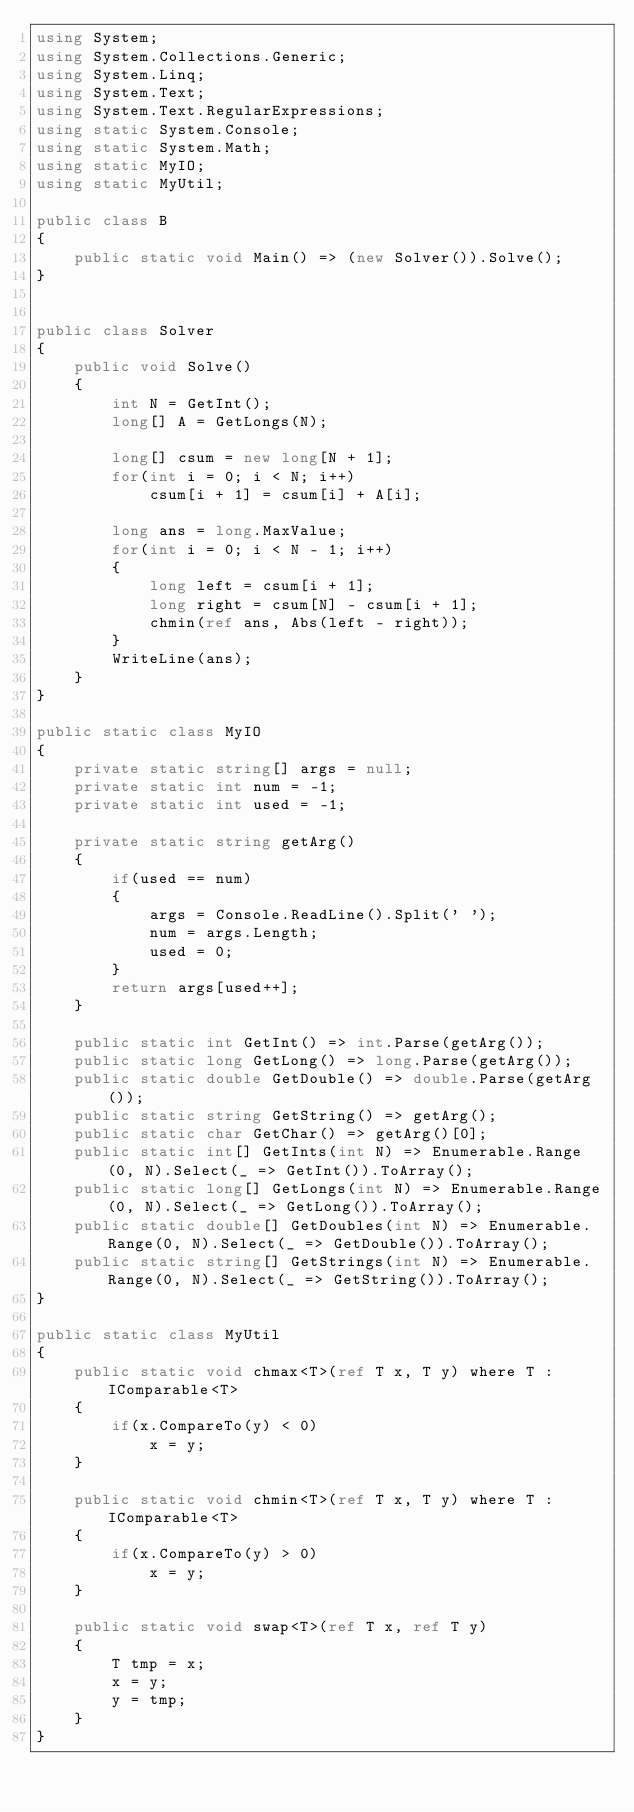<code> <loc_0><loc_0><loc_500><loc_500><_C#_>using System;
using System.Collections.Generic;
using System.Linq;
using System.Text;
using System.Text.RegularExpressions;
using static System.Console;
using static System.Math;
using static MyIO;
using static MyUtil;

public class B
{
	public static void Main() => (new Solver()).Solve();
}


public class Solver
{
	public void Solve()
	{
		int N = GetInt();
		long[] A = GetLongs(N);

		long[] csum = new long[N + 1];
		for(int i = 0; i < N; i++)
			csum[i + 1] = csum[i] + A[i];

		long ans = long.MaxValue;
		for(int i = 0; i < N - 1; i++)
		{
			long left = csum[i + 1];
			long right = csum[N] - csum[i + 1];
			chmin(ref ans, Abs(left - right));
		}
		WriteLine(ans);
	}
}

public static class MyIO
{
	private static string[] args = null;
	private static int num = -1;
	private static int used = -1;

	private static string getArg()
	{
		if(used == num)
		{
			args = Console.ReadLine().Split(' ');
			num = args.Length;
			used = 0;
		}
		return args[used++];
	}

	public static int GetInt() => int.Parse(getArg());
	public static long GetLong() => long.Parse(getArg());
	public static double GetDouble() => double.Parse(getArg());
	public static string GetString() => getArg();
	public static char GetChar() => getArg()[0];
	public static int[] GetInts(int N) => Enumerable.Range(0, N).Select(_ => GetInt()).ToArray();
	public static long[] GetLongs(int N) => Enumerable.Range(0, N).Select(_ => GetLong()).ToArray();
	public static double[] GetDoubles(int N) => Enumerable.Range(0, N).Select(_ => GetDouble()).ToArray();
	public static string[] GetStrings(int N) => Enumerable.Range(0, N).Select(_ => GetString()).ToArray();
}

public static class MyUtil
{
	public static void chmax<T>(ref T x, T y) where T : IComparable<T>
	{
		if(x.CompareTo(y) < 0)
			x = y;
	}

	public static void chmin<T>(ref T x, T y) where T : IComparable<T>
	{
		if(x.CompareTo(y) > 0)
			x = y;
	}

	public static void swap<T>(ref T x, ref T y)
	{
		T tmp = x;
		x = y;
		y = tmp;
	}
}</code> 